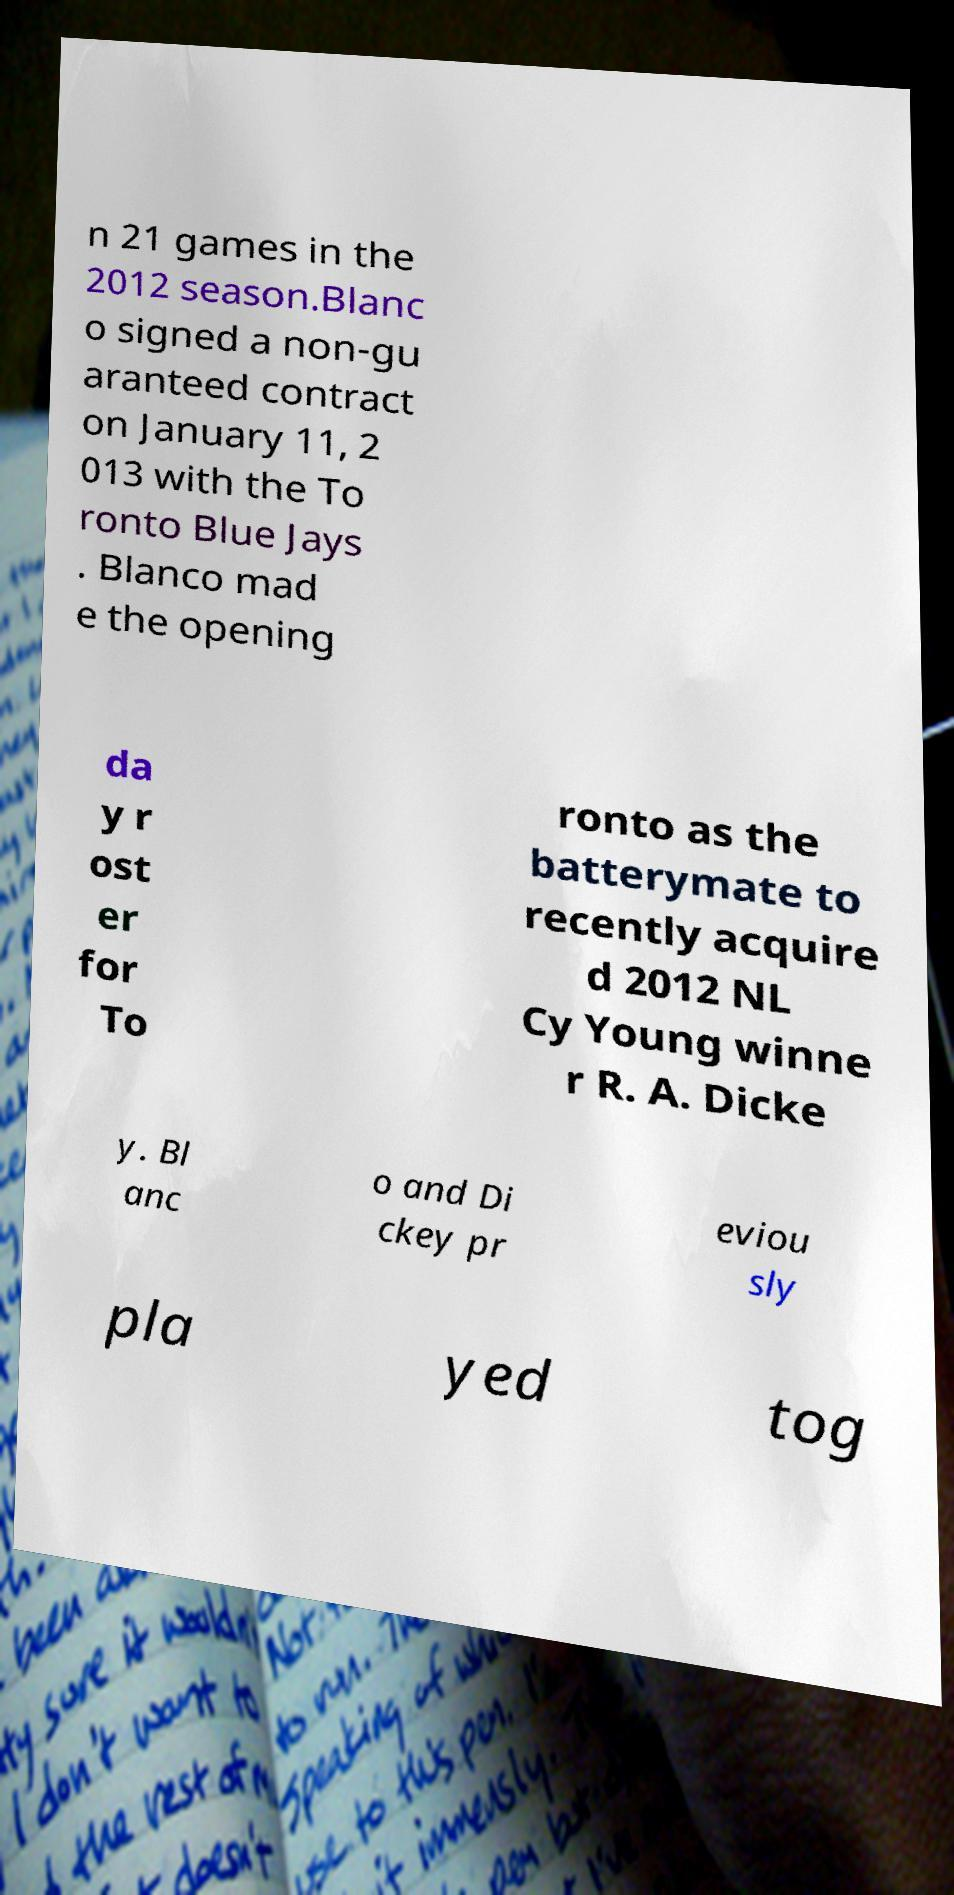Can you read and provide the text displayed in the image?This photo seems to have some interesting text. Can you extract and type it out for me? n 21 games in the 2012 season.Blanc o signed a non-gu aranteed contract on January 11, 2 013 with the To ronto Blue Jays . Blanco mad e the opening da y r ost er for To ronto as the batterymate to recently acquire d 2012 NL Cy Young winne r R. A. Dicke y. Bl anc o and Di ckey pr eviou sly pla yed tog 